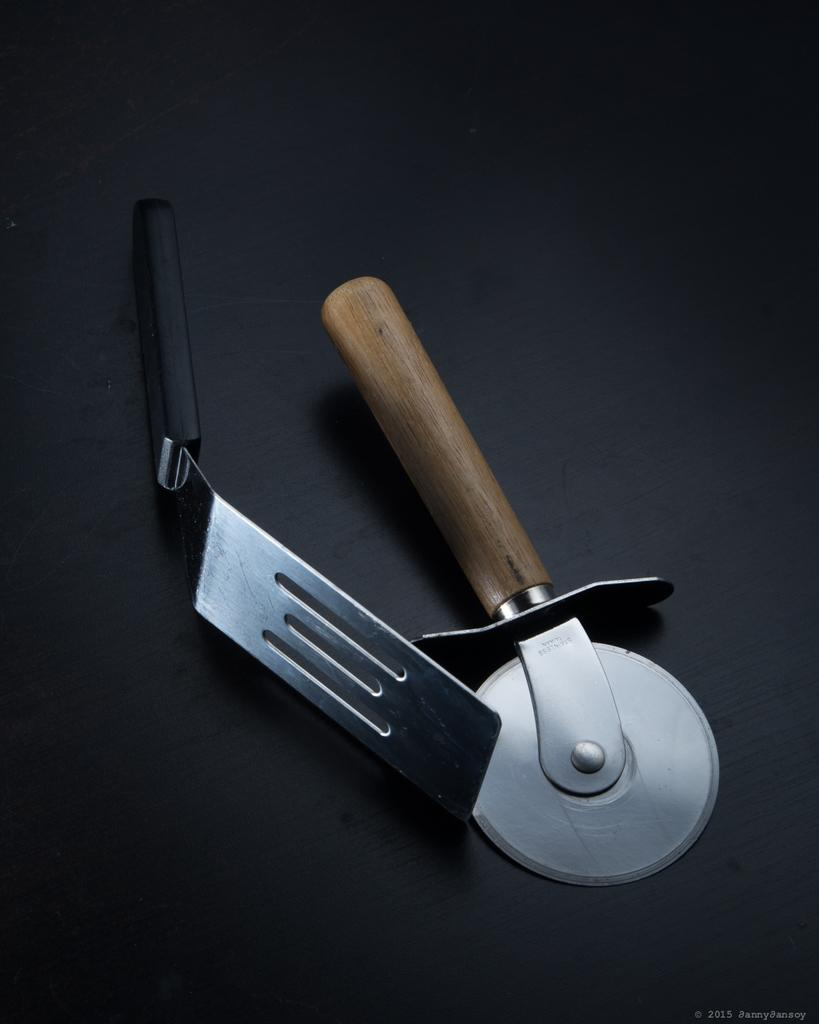What type of kitchen utensil is present in the image? There is a cutter in the image. What other utensil can be seen in the image? There is a spoon in the image. What type of pain is the cutter causing in the image? There is no indication of pain in the image, and the cutter is not causing any pain. How does the behavior of the spoon change throughout the image? The spoon does not exhibit any behavior in the image, as it is an inanimate object. 